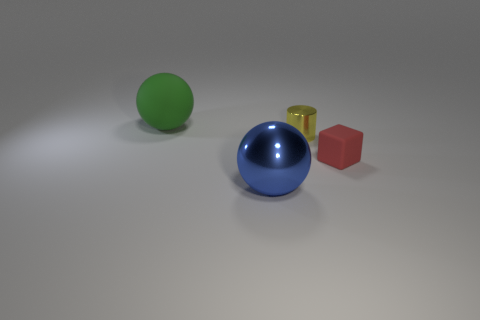Add 2 large cyan metallic objects. How many objects exist? 6 Subtract all blocks. How many objects are left? 3 Add 2 large green balls. How many large green balls are left? 3 Add 2 tiny yellow matte objects. How many tiny yellow matte objects exist? 2 Subtract 0 gray cylinders. How many objects are left? 4 Subtract all cyan matte cubes. Subtract all big rubber objects. How many objects are left? 3 